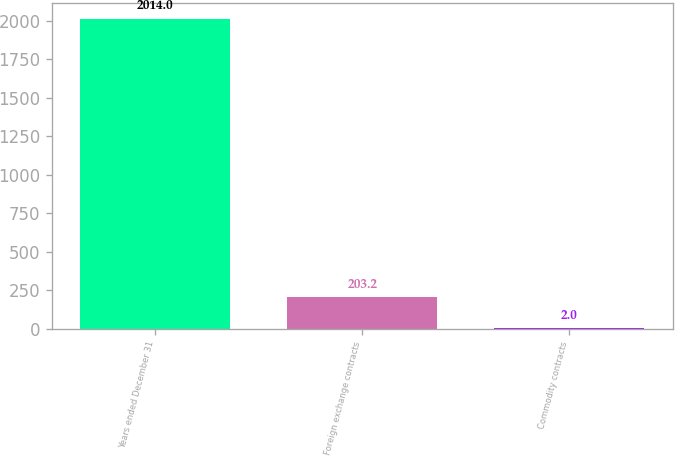Convert chart. <chart><loc_0><loc_0><loc_500><loc_500><bar_chart><fcel>Years ended December 31<fcel>Foreign exchange contracts<fcel>Commodity contracts<nl><fcel>2014<fcel>203.2<fcel>2<nl></chart> 